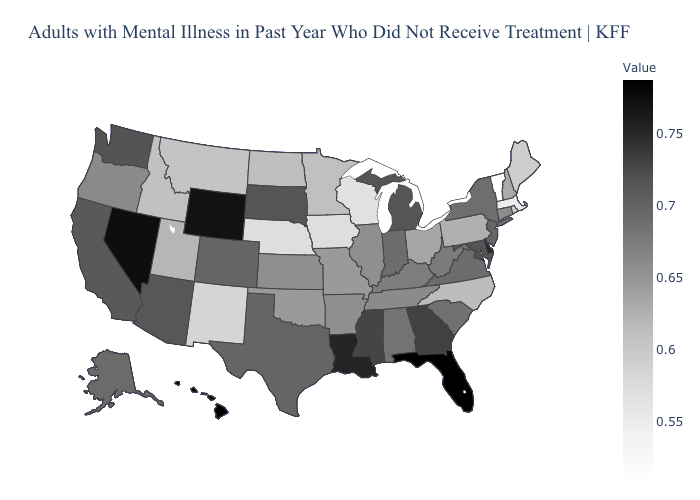Which states have the lowest value in the USA?
Concise answer only. Vermont. Which states have the lowest value in the MidWest?
Keep it brief. Wisconsin. Among the states that border Georgia , which have the lowest value?
Be succinct. North Carolina. Which states hav the highest value in the South?
Write a very short answer. Florida. Does the map have missing data?
Be succinct. No. 